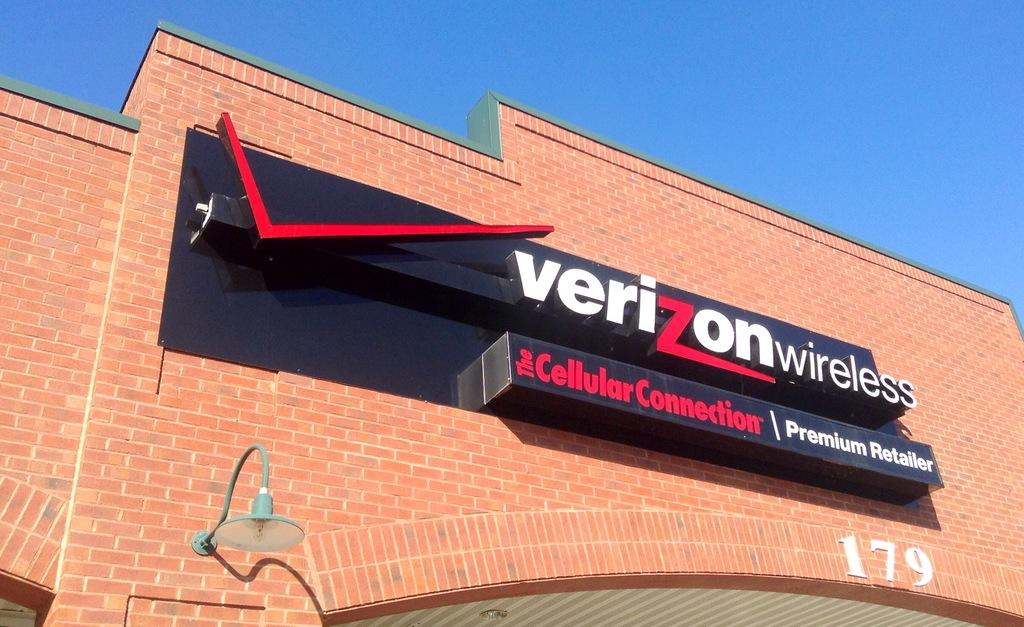<image>
Present a compact description of the photo's key features. A brick building has a Verizon wireless sign on it. 